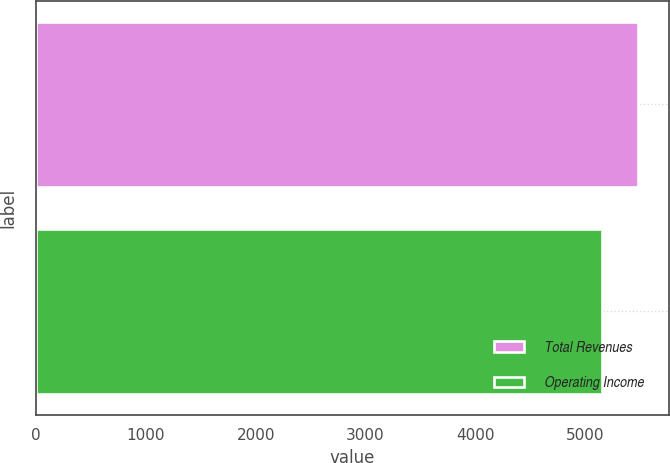<chart> <loc_0><loc_0><loc_500><loc_500><bar_chart><fcel>Total Revenues<fcel>Operating Income<nl><fcel>5483<fcel>5153<nl></chart> 